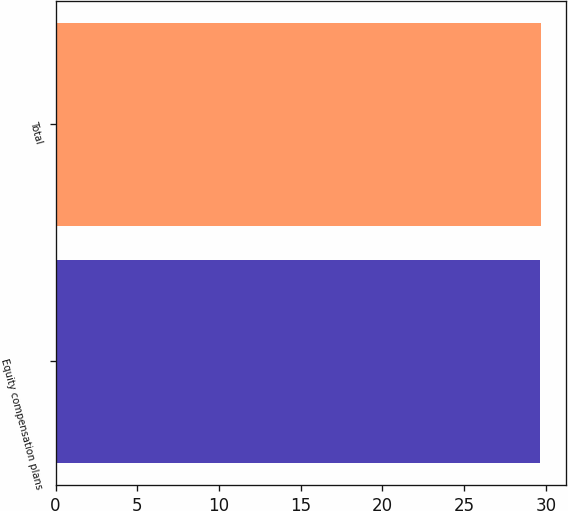<chart> <loc_0><loc_0><loc_500><loc_500><bar_chart><fcel>Equity compensation plans<fcel>Total<nl><fcel>29.62<fcel>29.72<nl></chart> 